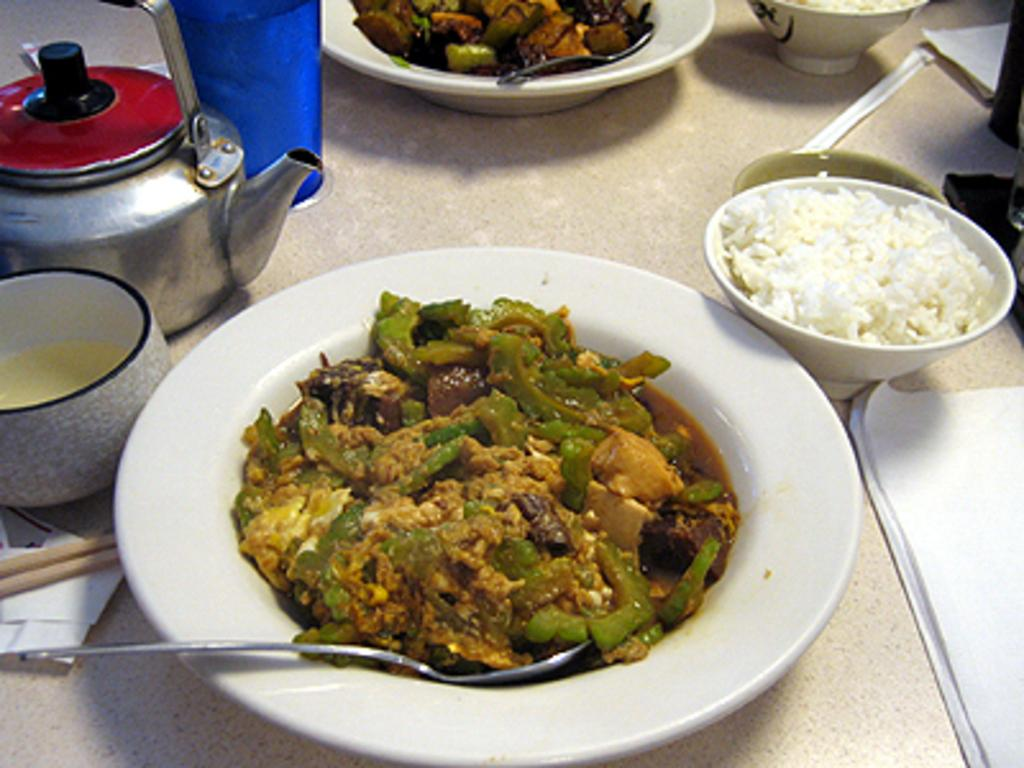What is on the plate that is visible in the image? There is a plate of food in the image. What other kitchen appliance or utensil can be seen in the image? There is a kettle in the image. Are there any other plates with food in the image? Yes, there is another plate with food in the image. What type of balls are being used to prepare the meal in the image? There are no balls present in the image, and no meal preparation is depicted. 